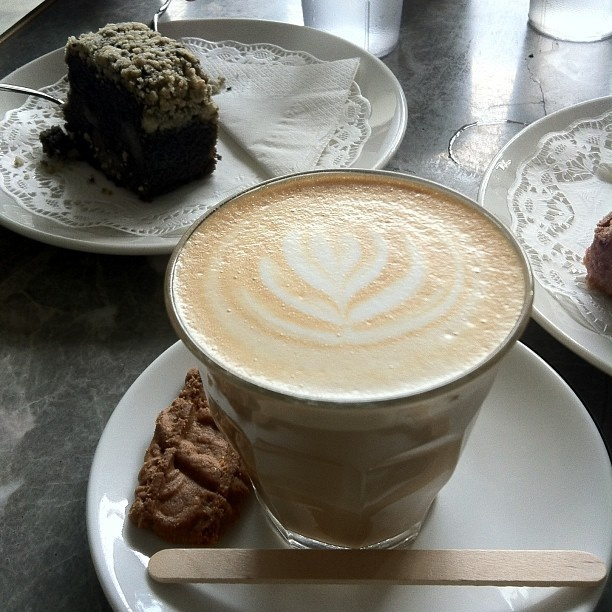Describe the objects in this image and their specific colors. I can see cup in darkgray, tan, beige, and black tones, cake in darkgray, black, gray, and darkgreen tones, cake in darkgray, black, maroon, and gray tones, cup in darkgray and lightgray tones, and cup in darkgray, white, gray, and lightgray tones in this image. 